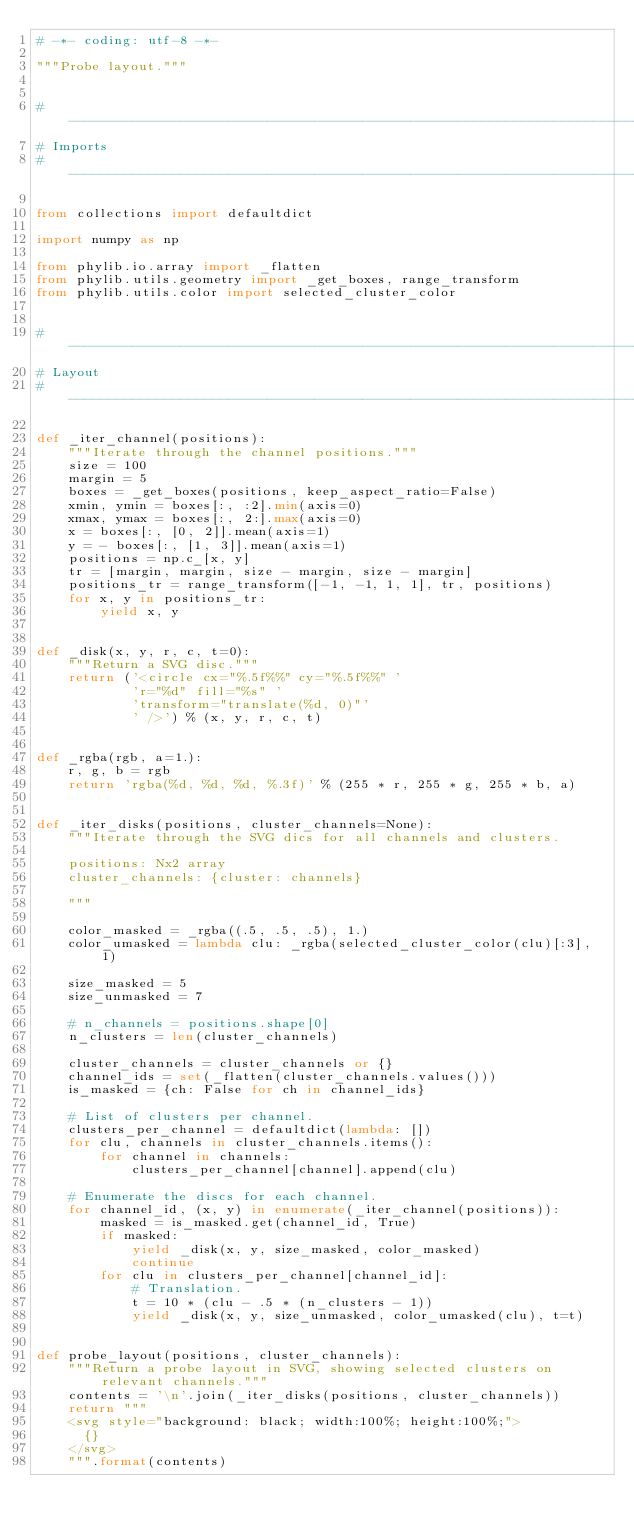Convert code to text. <code><loc_0><loc_0><loc_500><loc_500><_Python_># -*- coding: utf-8 -*-

"""Probe layout."""


#------------------------------------------------------------------------------
# Imports
#------------------------------------------------------------------------------

from collections import defaultdict

import numpy as np

from phylib.io.array import _flatten
from phylib.utils.geometry import _get_boxes, range_transform
from phylib.utils.color import selected_cluster_color


#------------------------------------------------------------------------------
# Layout
#------------------------------------------------------------------------------

def _iter_channel(positions):
    """Iterate through the channel positions."""
    size = 100
    margin = 5
    boxes = _get_boxes(positions, keep_aspect_ratio=False)
    xmin, ymin = boxes[:, :2].min(axis=0)
    xmax, ymax = boxes[:, 2:].max(axis=0)
    x = boxes[:, [0, 2]].mean(axis=1)
    y = - boxes[:, [1, 3]].mean(axis=1)
    positions = np.c_[x, y]
    tr = [margin, margin, size - margin, size - margin]
    positions_tr = range_transform([-1, -1, 1, 1], tr, positions)
    for x, y in positions_tr:
        yield x, y


def _disk(x, y, r, c, t=0):
    """Return a SVG disc."""
    return ('<circle cx="%.5f%%" cy="%.5f%%" '
            'r="%d" fill="%s" '
            'transform="translate(%d, 0)"'
            ' />') % (x, y, r, c, t)


def _rgba(rgb, a=1.):
    r, g, b = rgb
    return 'rgba(%d, %d, %d, %.3f)' % (255 * r, 255 * g, 255 * b, a)


def _iter_disks(positions, cluster_channels=None):
    """Iterate through the SVG dics for all channels and clusters.

    positions: Nx2 array
    cluster_channels: {cluster: channels}

    """

    color_masked = _rgba((.5, .5, .5), 1.)
    color_umasked = lambda clu: _rgba(selected_cluster_color(clu)[:3], 1)

    size_masked = 5
    size_unmasked = 7

    # n_channels = positions.shape[0]
    n_clusters = len(cluster_channels)

    cluster_channels = cluster_channels or {}
    channel_ids = set(_flatten(cluster_channels.values()))
    is_masked = {ch: False for ch in channel_ids}

    # List of clusters per channel.
    clusters_per_channel = defaultdict(lambda: [])
    for clu, channels in cluster_channels.items():
        for channel in channels:
            clusters_per_channel[channel].append(clu)

    # Enumerate the discs for each channel.
    for channel_id, (x, y) in enumerate(_iter_channel(positions)):
        masked = is_masked.get(channel_id, True)
        if masked:
            yield _disk(x, y, size_masked, color_masked)
            continue
        for clu in clusters_per_channel[channel_id]:
            # Translation.
            t = 10 * (clu - .5 * (n_clusters - 1))
            yield _disk(x, y, size_unmasked, color_umasked(clu), t=t)


def probe_layout(positions, cluster_channels):
    """Return a probe layout in SVG, showing selected clusters on relevant channels."""
    contents = '\n'.join(_iter_disks(positions, cluster_channels))
    return """
    <svg style="background: black; width:100%; height:100%;">
      {}
    </svg>
    """.format(contents)
</code> 